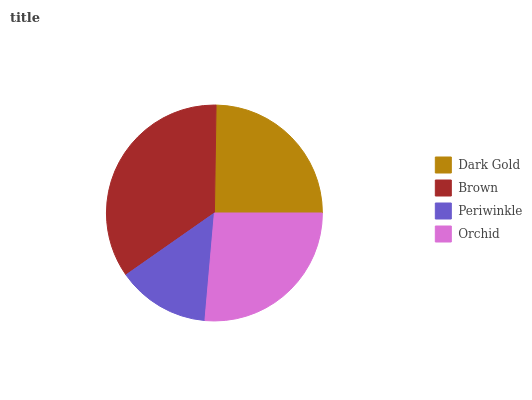Is Periwinkle the minimum?
Answer yes or no. Yes. Is Brown the maximum?
Answer yes or no. Yes. Is Brown the minimum?
Answer yes or no. No. Is Periwinkle the maximum?
Answer yes or no. No. Is Brown greater than Periwinkle?
Answer yes or no. Yes. Is Periwinkle less than Brown?
Answer yes or no. Yes. Is Periwinkle greater than Brown?
Answer yes or no. No. Is Brown less than Periwinkle?
Answer yes or no. No. Is Orchid the high median?
Answer yes or no. Yes. Is Dark Gold the low median?
Answer yes or no. Yes. Is Brown the high median?
Answer yes or no. No. Is Orchid the low median?
Answer yes or no. No. 